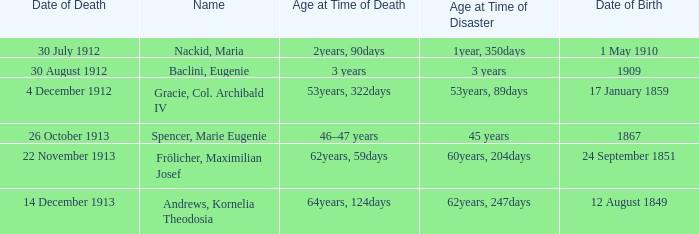Can you parse all the data within this table? {'header': ['Date of Death', 'Name', 'Age at Time of Death', 'Age at Time of Disaster', 'Date of Birth'], 'rows': [['30 July 1912', 'Nackid, Maria', '2years, 90days', '1year, 350days', '1 May 1910'], ['30 August 1912', 'Baclini, Eugenie', '3 years', '3 years', '1909'], ['4 December 1912', 'Gracie, Col. Archibald IV', '53years, 322days', '53years, 89days', '17 January 1859'], ['26 October 1913', 'Spencer, Marie Eugenie', '46–47 years', '45 years', '1867'], ['22 November 1913', 'Frölicher, Maximilian Josef', '62years, 59days', '60years, 204days', '24 September 1851'], ['14 December 1913', 'Andrews, Kornelia Theodosia', '64years, 124days', '62years, 247days', '12 August 1849']]} When did the person born 24 September 1851 pass away? 22 November 1913. 